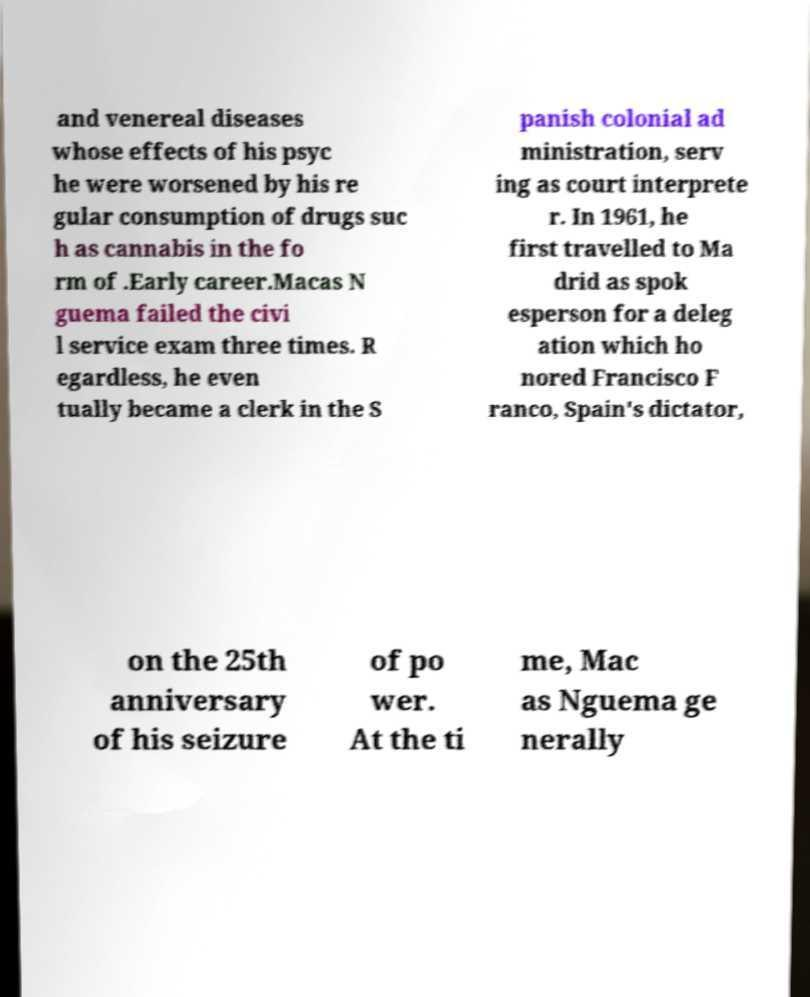There's text embedded in this image that I need extracted. Can you transcribe it verbatim? and venereal diseases whose effects of his psyc he were worsened by his re gular consumption of drugs suc h as cannabis in the fo rm of .Early career.Macas N guema failed the civi l service exam three times. R egardless, he even tually became a clerk in the S panish colonial ad ministration, serv ing as court interprete r. In 1961, he first travelled to Ma drid as spok esperson for a deleg ation which ho nored Francisco F ranco, Spain's dictator, on the 25th anniversary of his seizure of po wer. At the ti me, Mac as Nguema ge nerally 